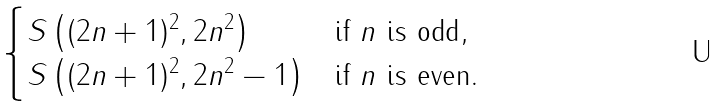Convert formula to latex. <formula><loc_0><loc_0><loc_500><loc_500>\begin{cases} S \left ( ( 2 n + 1 ) ^ { 2 } , 2 n ^ { 2 } \right ) & \text {if $n$ is odd} , \\ S \left ( ( 2 n + 1 ) ^ { 2 } , 2 n ^ { 2 } - 1 \right ) & \text {if $n$ is even} . \end{cases}</formula> 